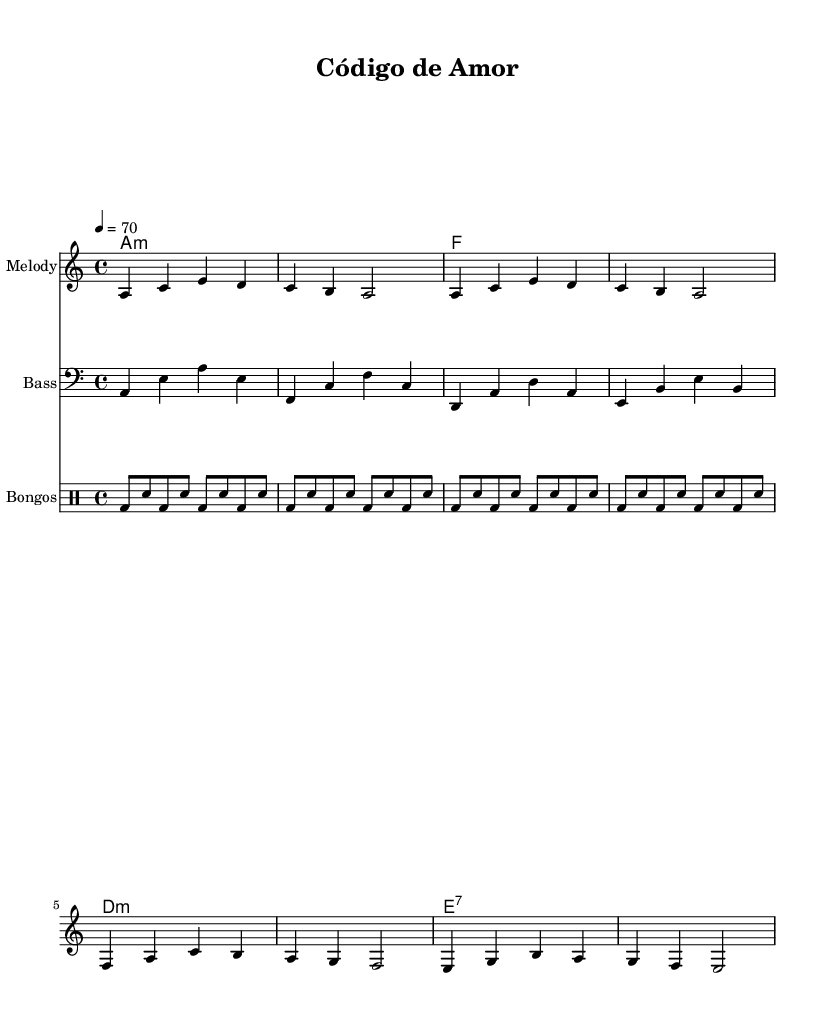What is the key signature of this music? The key signature is A minor, which has no sharps or flats (indicated by the absence of any accidentals in the key signature area).
Answer: A minor What is the time signature of this music? The time signature is 4/4, as indicated at the beginning of the score, which means there are four beats per measure and the quarter note gets one beat.
Answer: 4/4 What is the tempo marking for this piece? The tempo marking indicates a speed of 70 beats per minute, which is specified by the notation "4 = 70" at the start of the score. This means the quarter note is counted at 70 beats per minute.
Answer: 70 How many bars are in the melody section? The melody contains 8 bars, as counted by the number of measures shown in the staff notation. Each set of notes separated by vertical lines (bars) represents one measure.
Answer: 8 What is the primary genre of this piece? The primary genre is bachata, as evidenced by the inclusion of instrumentation typical of Latin music and the rhythmic feel found in the bongos accompaniment.
Answer: Bachata Which instruments are included in this score? The score includes a melody (potentially a lead instrument), bass, chord names, and bongos, which contribute to the overall sound typical of a mellow bachata piece.
Answer: Melody, Bass, Bongos 